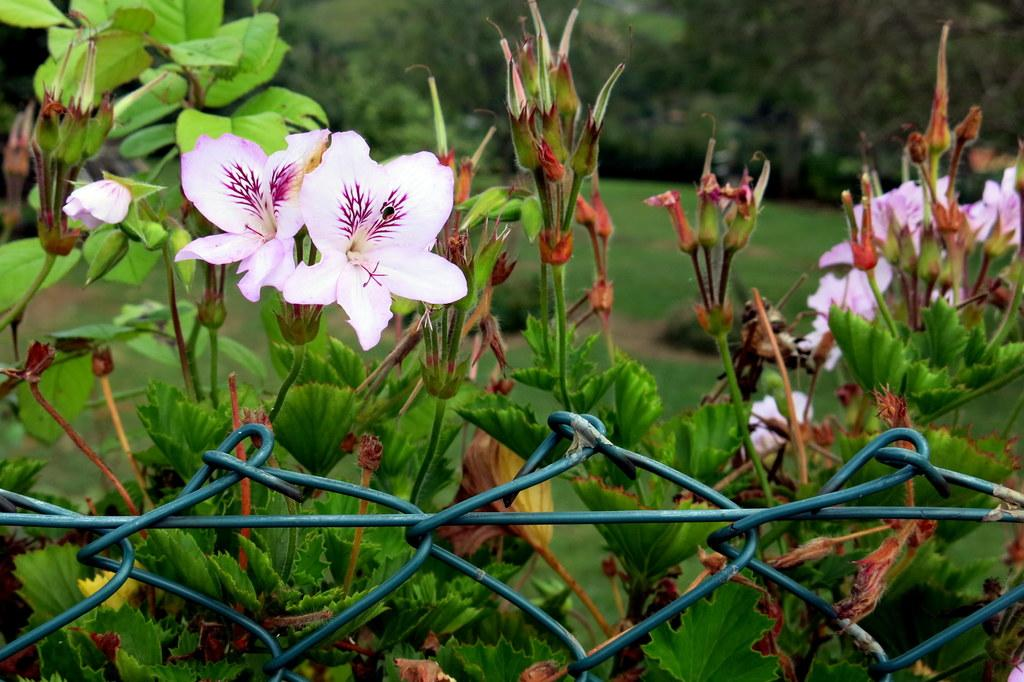What is located in the foreground of the image? There is fencing in the foreground of the image. What types of plants can be seen in the image? There are flowers and buds on plants in the image. What can be seen in the background of the image? There is grassland and trees in the background of the image. What type of thread is being used to tie the pail to the tree in the image? There is no pail or thread present in the image. How many rings can be seen on the fingers of the person in the image? There is no person present in the image. 